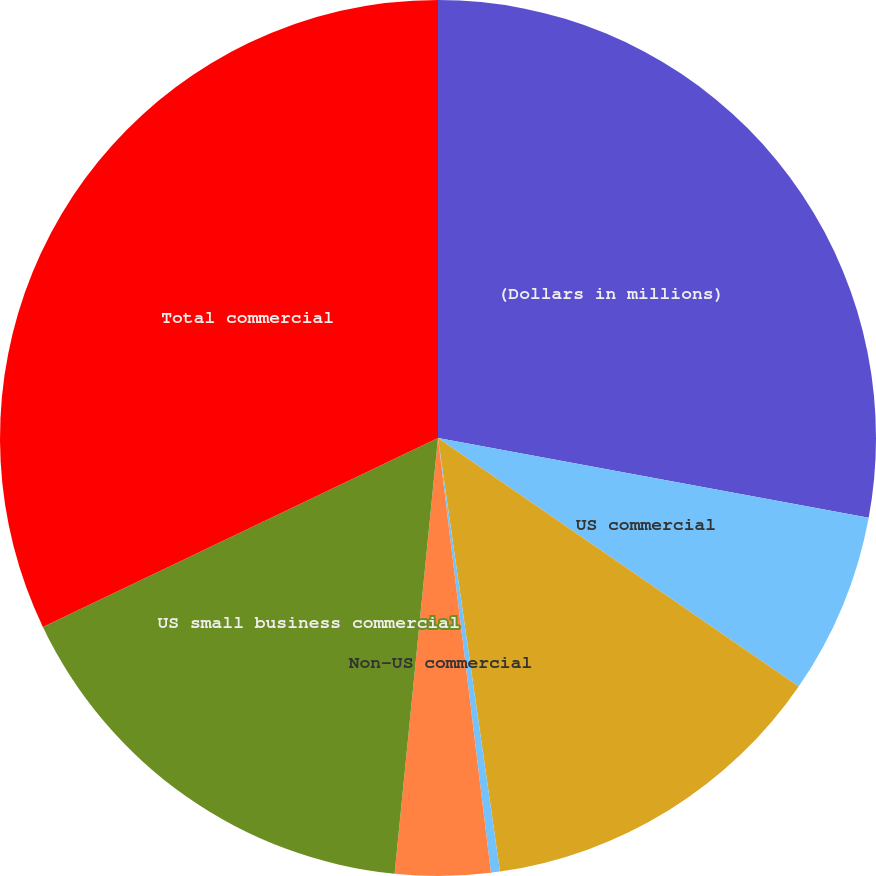Convert chart. <chart><loc_0><loc_0><loc_500><loc_500><pie_chart><fcel>(Dollars in millions)<fcel>US commercial<fcel>Commercial real estate<fcel>Commercial lease financing<fcel>Non-US commercial<fcel>US small business commercial<fcel>Total commercial<nl><fcel>27.91%<fcel>6.69%<fcel>13.14%<fcel>0.33%<fcel>3.51%<fcel>16.32%<fcel>32.1%<nl></chart> 